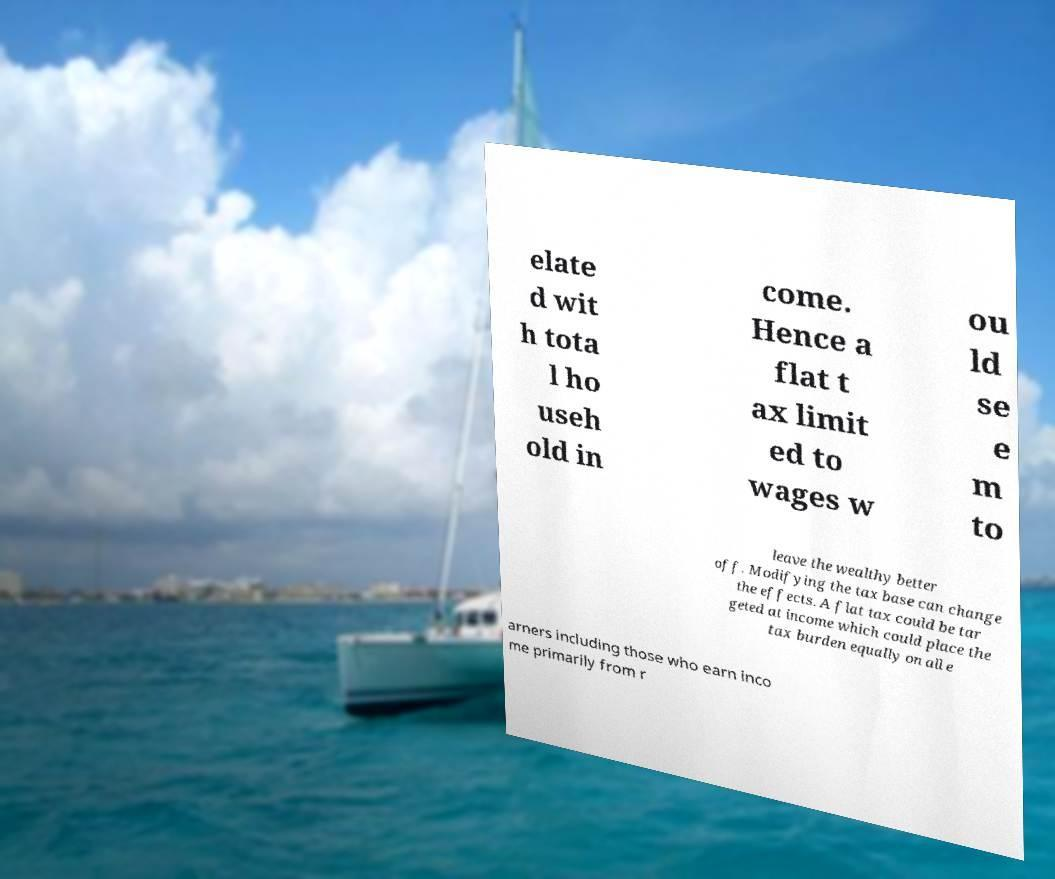There's text embedded in this image that I need extracted. Can you transcribe it verbatim? elate d wit h tota l ho useh old in come. Hence a flat t ax limit ed to wages w ou ld se e m to leave the wealthy better off. Modifying the tax base can change the effects. A flat tax could be tar geted at income which could place the tax burden equally on all e arners including those who earn inco me primarily from r 